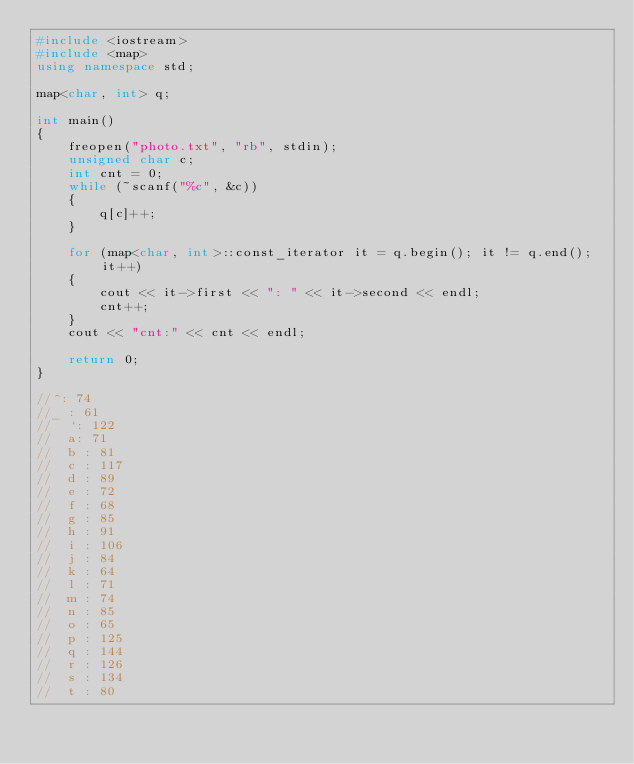<code> <loc_0><loc_0><loc_500><loc_500><_C++_>#include <iostream>
#include <map>
using namespace std;

map<char, int> q;

int main()
{
	freopen("photo.txt", "rb", stdin);
	unsigned char c;
	int cnt = 0;
	while (~scanf("%c", &c))
	{
		q[c]++;
	}

	for (map<char, int>::const_iterator it = q.begin(); it != q.end(); it++)
	{
		cout << it->first << ": " << it->second << endl;
		cnt++;
	}
	cout << "cnt:" << cnt << endl;

	return 0;
}

//^: 74
//_ : 61
//	`: 122
//	a: 71
//	b : 81
//	c : 117
//	d : 89
//	e : 72
//	f : 68
//	g : 85
//	h : 91
//	i : 106
//	j : 84
//	k : 64
//	l : 71
//	m : 74
//	n : 85
//	o : 65
//	p : 125
//	q : 144
//	r : 126
//	s : 134
//	t : 80</code> 